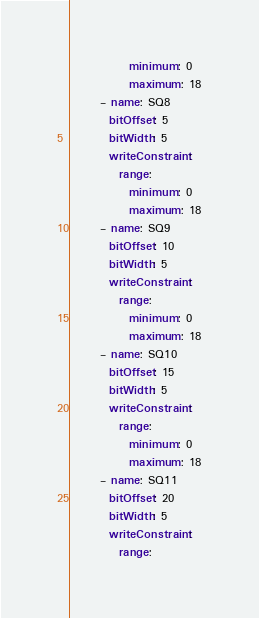Convert code to text. <code><loc_0><loc_0><loc_500><loc_500><_YAML_>            minimum: 0
            maximum: 18
      - name: SQ8
        bitOffset: 5
        bitWidth: 5
        writeConstraint:
          range:
            minimum: 0
            maximum: 18
      - name: SQ9
        bitOffset: 10
        bitWidth: 5
        writeConstraint:
          range:
            minimum: 0
            maximum: 18
      - name: SQ10
        bitOffset: 15
        bitWidth: 5
        writeConstraint:
          range:
            minimum: 0
            maximum: 18
      - name: SQ11
        bitOffset: 20
        bitWidth: 5
        writeConstraint:
          range:</code> 